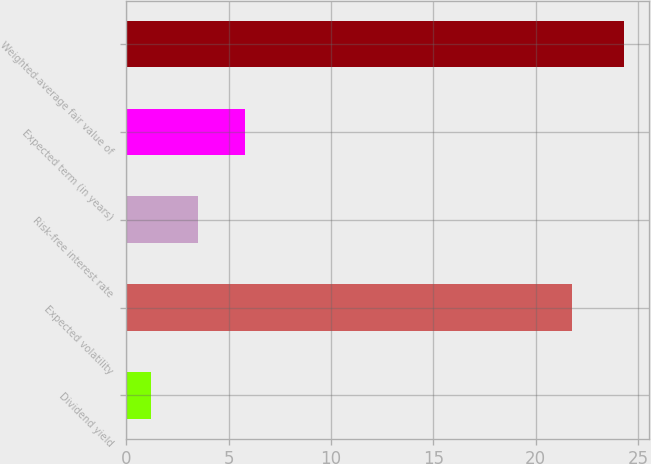Convert chart to OTSL. <chart><loc_0><loc_0><loc_500><loc_500><bar_chart><fcel>Dividend yield<fcel>Expected volatility<fcel>Risk-free interest rate<fcel>Expected term (in years)<fcel>Weighted-average fair value of<nl><fcel>1.2<fcel>21.8<fcel>3.51<fcel>5.82<fcel>24.34<nl></chart> 